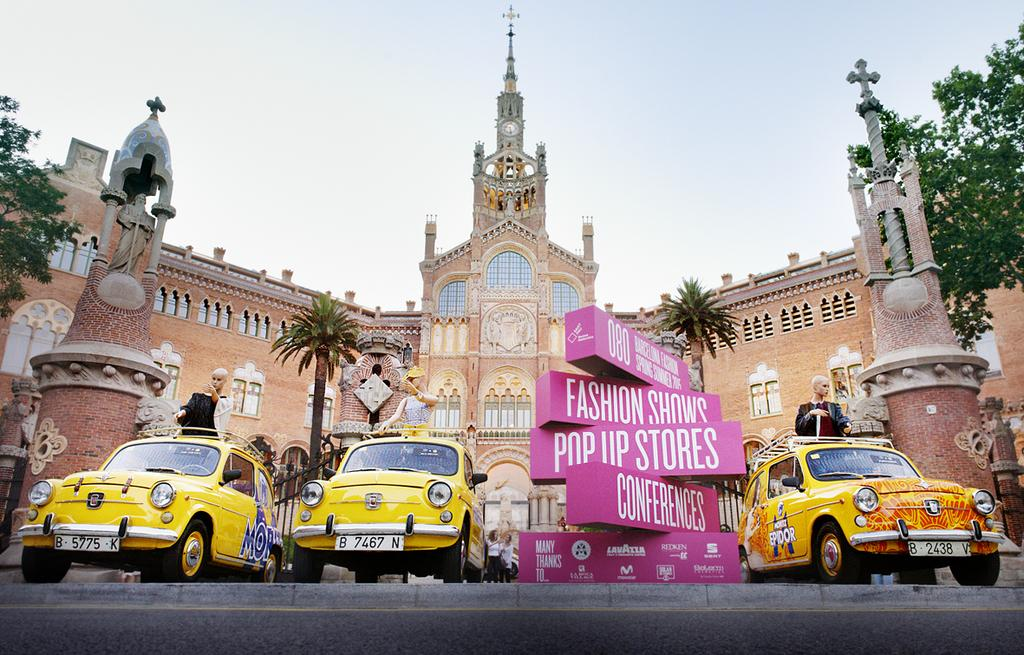<image>
Present a compact description of the photo's key features. The pink Fashion Shows Pop Up Stores Conferences sign is displayed along with 3 yellow cars before a grand and beautiful building. 